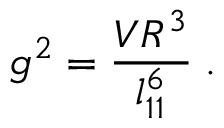Convert formula to latex. <formula><loc_0><loc_0><loc_500><loc_500>g ^ { 2 } = \frac { V R ^ { 3 } } { l _ { 1 1 } ^ { 6 } } \, .</formula> 